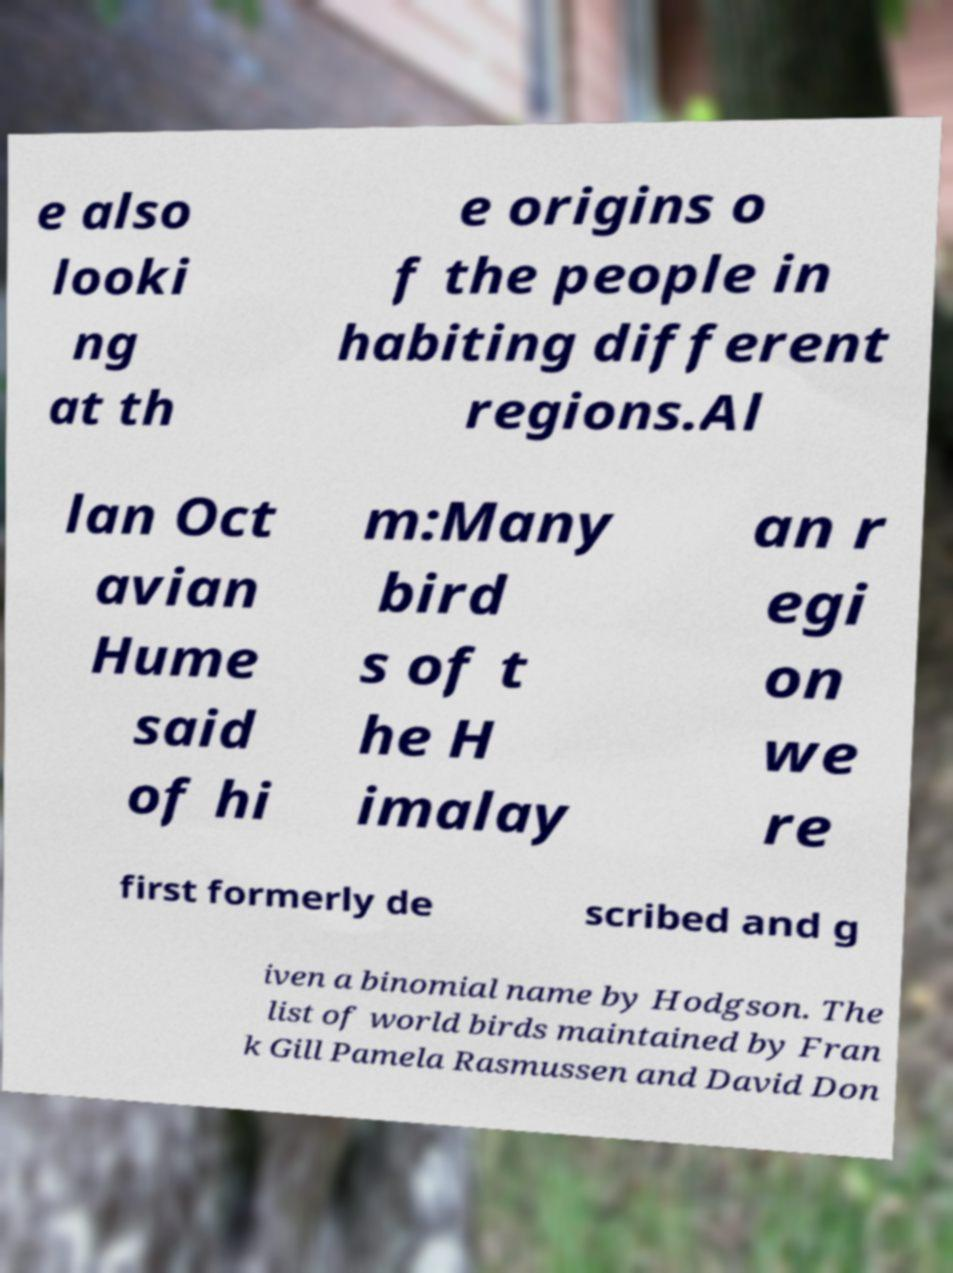Can you read and provide the text displayed in the image?This photo seems to have some interesting text. Can you extract and type it out for me? e also looki ng at th e origins o f the people in habiting different regions.Al lan Oct avian Hume said of hi m:Many bird s of t he H imalay an r egi on we re first formerly de scribed and g iven a binomial name by Hodgson. The list of world birds maintained by Fran k Gill Pamela Rasmussen and David Don 